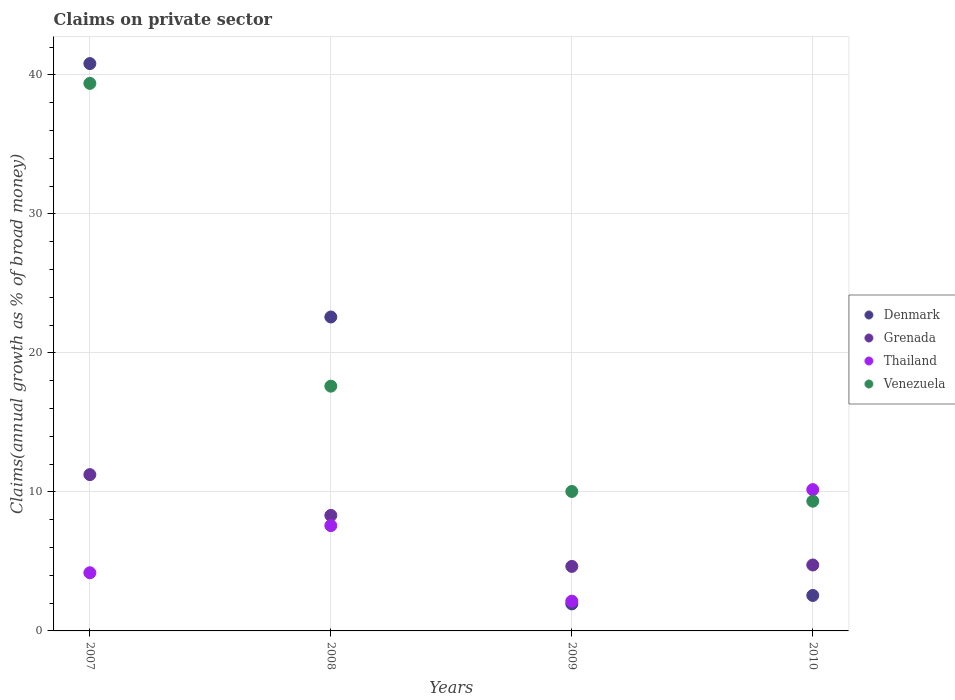How many different coloured dotlines are there?
Provide a short and direct response. 4. Is the number of dotlines equal to the number of legend labels?
Offer a terse response. Yes. What is the percentage of broad money claimed on private sector in Grenada in 2008?
Provide a succinct answer. 8.31. Across all years, what is the maximum percentage of broad money claimed on private sector in Denmark?
Your answer should be very brief. 40.82. Across all years, what is the minimum percentage of broad money claimed on private sector in Venezuela?
Your answer should be very brief. 9.33. In which year was the percentage of broad money claimed on private sector in Grenada minimum?
Your response must be concise. 2009. What is the total percentage of broad money claimed on private sector in Grenada in the graph?
Your response must be concise. 28.94. What is the difference between the percentage of broad money claimed on private sector in Venezuela in 2008 and that in 2010?
Your answer should be compact. 8.27. What is the difference between the percentage of broad money claimed on private sector in Venezuela in 2010 and the percentage of broad money claimed on private sector in Grenada in 2009?
Your answer should be compact. 4.69. What is the average percentage of broad money claimed on private sector in Thailand per year?
Make the answer very short. 6.02. In the year 2010, what is the difference between the percentage of broad money claimed on private sector in Denmark and percentage of broad money claimed on private sector in Thailand?
Provide a short and direct response. -7.61. What is the ratio of the percentage of broad money claimed on private sector in Grenada in 2007 to that in 2009?
Give a very brief answer. 2.42. What is the difference between the highest and the second highest percentage of broad money claimed on private sector in Thailand?
Give a very brief answer. 2.59. What is the difference between the highest and the lowest percentage of broad money claimed on private sector in Venezuela?
Keep it short and to the point. 30.06. Is the sum of the percentage of broad money claimed on private sector in Venezuela in 2007 and 2010 greater than the maximum percentage of broad money claimed on private sector in Denmark across all years?
Your answer should be very brief. Yes. Is it the case that in every year, the sum of the percentage of broad money claimed on private sector in Thailand and percentage of broad money claimed on private sector in Venezuela  is greater than the sum of percentage of broad money claimed on private sector in Denmark and percentage of broad money claimed on private sector in Grenada?
Provide a succinct answer. No. Is it the case that in every year, the sum of the percentage of broad money claimed on private sector in Venezuela and percentage of broad money claimed on private sector in Denmark  is greater than the percentage of broad money claimed on private sector in Grenada?
Offer a terse response. Yes. Is the percentage of broad money claimed on private sector in Venezuela strictly greater than the percentage of broad money claimed on private sector in Denmark over the years?
Your response must be concise. No. Is the percentage of broad money claimed on private sector in Denmark strictly less than the percentage of broad money claimed on private sector in Grenada over the years?
Provide a succinct answer. No. How many dotlines are there?
Offer a terse response. 4. What is the difference between two consecutive major ticks on the Y-axis?
Your response must be concise. 10. Does the graph contain grids?
Offer a very short reply. Yes. Where does the legend appear in the graph?
Offer a terse response. Center right. How many legend labels are there?
Offer a very short reply. 4. What is the title of the graph?
Offer a terse response. Claims on private sector. What is the label or title of the Y-axis?
Give a very brief answer. Claims(annual growth as % of broad money). What is the Claims(annual growth as % of broad money) in Denmark in 2007?
Make the answer very short. 40.82. What is the Claims(annual growth as % of broad money) of Grenada in 2007?
Provide a short and direct response. 11.25. What is the Claims(annual growth as % of broad money) of Thailand in 2007?
Make the answer very short. 4.18. What is the Claims(annual growth as % of broad money) of Venezuela in 2007?
Give a very brief answer. 39.39. What is the Claims(annual growth as % of broad money) in Denmark in 2008?
Provide a short and direct response. 22.59. What is the Claims(annual growth as % of broad money) of Grenada in 2008?
Keep it short and to the point. 8.31. What is the Claims(annual growth as % of broad money) of Thailand in 2008?
Provide a succinct answer. 7.58. What is the Claims(annual growth as % of broad money) of Venezuela in 2008?
Ensure brevity in your answer.  17.61. What is the Claims(annual growth as % of broad money) of Denmark in 2009?
Provide a succinct answer. 1.94. What is the Claims(annual growth as % of broad money) of Grenada in 2009?
Your answer should be very brief. 4.64. What is the Claims(annual growth as % of broad money) of Thailand in 2009?
Ensure brevity in your answer.  2.14. What is the Claims(annual growth as % of broad money) in Venezuela in 2009?
Ensure brevity in your answer.  10.03. What is the Claims(annual growth as % of broad money) in Denmark in 2010?
Give a very brief answer. 2.55. What is the Claims(annual growth as % of broad money) of Grenada in 2010?
Your response must be concise. 4.75. What is the Claims(annual growth as % of broad money) in Thailand in 2010?
Give a very brief answer. 10.17. What is the Claims(annual growth as % of broad money) in Venezuela in 2010?
Provide a succinct answer. 9.33. Across all years, what is the maximum Claims(annual growth as % of broad money) in Denmark?
Your answer should be very brief. 40.82. Across all years, what is the maximum Claims(annual growth as % of broad money) of Grenada?
Your response must be concise. 11.25. Across all years, what is the maximum Claims(annual growth as % of broad money) in Thailand?
Ensure brevity in your answer.  10.17. Across all years, what is the maximum Claims(annual growth as % of broad money) of Venezuela?
Provide a succinct answer. 39.39. Across all years, what is the minimum Claims(annual growth as % of broad money) in Denmark?
Provide a succinct answer. 1.94. Across all years, what is the minimum Claims(annual growth as % of broad money) in Grenada?
Your response must be concise. 4.64. Across all years, what is the minimum Claims(annual growth as % of broad money) of Thailand?
Give a very brief answer. 2.14. Across all years, what is the minimum Claims(annual growth as % of broad money) of Venezuela?
Offer a terse response. 9.33. What is the total Claims(annual growth as % of broad money) in Denmark in the graph?
Your response must be concise. 67.9. What is the total Claims(annual growth as % of broad money) of Grenada in the graph?
Provide a succinct answer. 28.94. What is the total Claims(annual growth as % of broad money) in Thailand in the graph?
Offer a very short reply. 24.07. What is the total Claims(annual growth as % of broad money) of Venezuela in the graph?
Ensure brevity in your answer.  76.37. What is the difference between the Claims(annual growth as % of broad money) in Denmark in 2007 and that in 2008?
Provide a succinct answer. 18.23. What is the difference between the Claims(annual growth as % of broad money) in Grenada in 2007 and that in 2008?
Offer a terse response. 2.93. What is the difference between the Claims(annual growth as % of broad money) in Thailand in 2007 and that in 2008?
Your answer should be very brief. -3.39. What is the difference between the Claims(annual growth as % of broad money) in Venezuela in 2007 and that in 2008?
Offer a terse response. 21.78. What is the difference between the Claims(annual growth as % of broad money) of Denmark in 2007 and that in 2009?
Give a very brief answer. 38.87. What is the difference between the Claims(annual growth as % of broad money) in Grenada in 2007 and that in 2009?
Your answer should be very brief. 6.6. What is the difference between the Claims(annual growth as % of broad money) in Thailand in 2007 and that in 2009?
Offer a terse response. 2.04. What is the difference between the Claims(annual growth as % of broad money) of Venezuela in 2007 and that in 2009?
Offer a very short reply. 29.36. What is the difference between the Claims(annual growth as % of broad money) of Denmark in 2007 and that in 2010?
Keep it short and to the point. 38.27. What is the difference between the Claims(annual growth as % of broad money) in Thailand in 2007 and that in 2010?
Make the answer very short. -5.98. What is the difference between the Claims(annual growth as % of broad money) in Venezuela in 2007 and that in 2010?
Offer a very short reply. 30.06. What is the difference between the Claims(annual growth as % of broad money) in Denmark in 2008 and that in 2009?
Provide a short and direct response. 20.64. What is the difference between the Claims(annual growth as % of broad money) of Grenada in 2008 and that in 2009?
Your answer should be very brief. 3.67. What is the difference between the Claims(annual growth as % of broad money) in Thailand in 2008 and that in 2009?
Provide a succinct answer. 5.44. What is the difference between the Claims(annual growth as % of broad money) in Venezuela in 2008 and that in 2009?
Give a very brief answer. 7.58. What is the difference between the Claims(annual growth as % of broad money) of Denmark in 2008 and that in 2010?
Your answer should be very brief. 20.03. What is the difference between the Claims(annual growth as % of broad money) of Grenada in 2008 and that in 2010?
Offer a very short reply. 3.57. What is the difference between the Claims(annual growth as % of broad money) in Thailand in 2008 and that in 2010?
Make the answer very short. -2.59. What is the difference between the Claims(annual growth as % of broad money) of Venezuela in 2008 and that in 2010?
Your response must be concise. 8.27. What is the difference between the Claims(annual growth as % of broad money) in Denmark in 2009 and that in 2010?
Your answer should be very brief. -0.61. What is the difference between the Claims(annual growth as % of broad money) of Grenada in 2009 and that in 2010?
Your response must be concise. -0.1. What is the difference between the Claims(annual growth as % of broad money) of Thailand in 2009 and that in 2010?
Your answer should be compact. -8.03. What is the difference between the Claims(annual growth as % of broad money) in Venezuela in 2009 and that in 2010?
Keep it short and to the point. 0.7. What is the difference between the Claims(annual growth as % of broad money) of Denmark in 2007 and the Claims(annual growth as % of broad money) of Grenada in 2008?
Your answer should be compact. 32.51. What is the difference between the Claims(annual growth as % of broad money) of Denmark in 2007 and the Claims(annual growth as % of broad money) of Thailand in 2008?
Ensure brevity in your answer.  33.24. What is the difference between the Claims(annual growth as % of broad money) in Denmark in 2007 and the Claims(annual growth as % of broad money) in Venezuela in 2008?
Your response must be concise. 23.21. What is the difference between the Claims(annual growth as % of broad money) of Grenada in 2007 and the Claims(annual growth as % of broad money) of Thailand in 2008?
Your answer should be very brief. 3.67. What is the difference between the Claims(annual growth as % of broad money) of Grenada in 2007 and the Claims(annual growth as % of broad money) of Venezuela in 2008?
Keep it short and to the point. -6.36. What is the difference between the Claims(annual growth as % of broad money) in Thailand in 2007 and the Claims(annual growth as % of broad money) in Venezuela in 2008?
Provide a short and direct response. -13.43. What is the difference between the Claims(annual growth as % of broad money) of Denmark in 2007 and the Claims(annual growth as % of broad money) of Grenada in 2009?
Provide a succinct answer. 36.18. What is the difference between the Claims(annual growth as % of broad money) in Denmark in 2007 and the Claims(annual growth as % of broad money) in Thailand in 2009?
Ensure brevity in your answer.  38.68. What is the difference between the Claims(annual growth as % of broad money) in Denmark in 2007 and the Claims(annual growth as % of broad money) in Venezuela in 2009?
Your response must be concise. 30.78. What is the difference between the Claims(annual growth as % of broad money) in Grenada in 2007 and the Claims(annual growth as % of broad money) in Thailand in 2009?
Offer a very short reply. 9.11. What is the difference between the Claims(annual growth as % of broad money) of Grenada in 2007 and the Claims(annual growth as % of broad money) of Venezuela in 2009?
Your answer should be very brief. 1.21. What is the difference between the Claims(annual growth as % of broad money) in Thailand in 2007 and the Claims(annual growth as % of broad money) in Venezuela in 2009?
Keep it short and to the point. -5.85. What is the difference between the Claims(annual growth as % of broad money) of Denmark in 2007 and the Claims(annual growth as % of broad money) of Grenada in 2010?
Offer a terse response. 36.07. What is the difference between the Claims(annual growth as % of broad money) of Denmark in 2007 and the Claims(annual growth as % of broad money) of Thailand in 2010?
Make the answer very short. 30.65. What is the difference between the Claims(annual growth as % of broad money) of Denmark in 2007 and the Claims(annual growth as % of broad money) of Venezuela in 2010?
Your answer should be very brief. 31.48. What is the difference between the Claims(annual growth as % of broad money) of Grenada in 2007 and the Claims(annual growth as % of broad money) of Thailand in 2010?
Provide a succinct answer. 1.08. What is the difference between the Claims(annual growth as % of broad money) of Grenada in 2007 and the Claims(annual growth as % of broad money) of Venezuela in 2010?
Keep it short and to the point. 1.91. What is the difference between the Claims(annual growth as % of broad money) in Thailand in 2007 and the Claims(annual growth as % of broad money) in Venezuela in 2010?
Make the answer very short. -5.15. What is the difference between the Claims(annual growth as % of broad money) in Denmark in 2008 and the Claims(annual growth as % of broad money) in Grenada in 2009?
Provide a succinct answer. 17.94. What is the difference between the Claims(annual growth as % of broad money) of Denmark in 2008 and the Claims(annual growth as % of broad money) of Thailand in 2009?
Offer a terse response. 20.45. What is the difference between the Claims(annual growth as % of broad money) in Denmark in 2008 and the Claims(annual growth as % of broad money) in Venezuela in 2009?
Provide a succinct answer. 12.55. What is the difference between the Claims(annual growth as % of broad money) in Grenada in 2008 and the Claims(annual growth as % of broad money) in Thailand in 2009?
Offer a very short reply. 6.17. What is the difference between the Claims(annual growth as % of broad money) of Grenada in 2008 and the Claims(annual growth as % of broad money) of Venezuela in 2009?
Offer a terse response. -1.72. What is the difference between the Claims(annual growth as % of broad money) in Thailand in 2008 and the Claims(annual growth as % of broad money) in Venezuela in 2009?
Your response must be concise. -2.46. What is the difference between the Claims(annual growth as % of broad money) of Denmark in 2008 and the Claims(annual growth as % of broad money) of Grenada in 2010?
Provide a succinct answer. 17.84. What is the difference between the Claims(annual growth as % of broad money) in Denmark in 2008 and the Claims(annual growth as % of broad money) in Thailand in 2010?
Provide a short and direct response. 12.42. What is the difference between the Claims(annual growth as % of broad money) in Denmark in 2008 and the Claims(annual growth as % of broad money) in Venezuela in 2010?
Provide a succinct answer. 13.25. What is the difference between the Claims(annual growth as % of broad money) in Grenada in 2008 and the Claims(annual growth as % of broad money) in Thailand in 2010?
Your answer should be compact. -1.86. What is the difference between the Claims(annual growth as % of broad money) in Grenada in 2008 and the Claims(annual growth as % of broad money) in Venezuela in 2010?
Your response must be concise. -1.02. What is the difference between the Claims(annual growth as % of broad money) of Thailand in 2008 and the Claims(annual growth as % of broad money) of Venezuela in 2010?
Provide a succinct answer. -1.76. What is the difference between the Claims(annual growth as % of broad money) of Denmark in 2009 and the Claims(annual growth as % of broad money) of Grenada in 2010?
Offer a very short reply. -2.8. What is the difference between the Claims(annual growth as % of broad money) of Denmark in 2009 and the Claims(annual growth as % of broad money) of Thailand in 2010?
Your answer should be compact. -8.22. What is the difference between the Claims(annual growth as % of broad money) of Denmark in 2009 and the Claims(annual growth as % of broad money) of Venezuela in 2010?
Your answer should be very brief. -7.39. What is the difference between the Claims(annual growth as % of broad money) in Grenada in 2009 and the Claims(annual growth as % of broad money) in Thailand in 2010?
Offer a very short reply. -5.52. What is the difference between the Claims(annual growth as % of broad money) of Grenada in 2009 and the Claims(annual growth as % of broad money) of Venezuela in 2010?
Make the answer very short. -4.69. What is the difference between the Claims(annual growth as % of broad money) in Thailand in 2009 and the Claims(annual growth as % of broad money) in Venezuela in 2010?
Give a very brief answer. -7.19. What is the average Claims(annual growth as % of broad money) of Denmark per year?
Offer a very short reply. 16.98. What is the average Claims(annual growth as % of broad money) of Grenada per year?
Make the answer very short. 7.24. What is the average Claims(annual growth as % of broad money) in Thailand per year?
Your response must be concise. 6.02. What is the average Claims(annual growth as % of broad money) in Venezuela per year?
Provide a short and direct response. 19.09. In the year 2007, what is the difference between the Claims(annual growth as % of broad money) of Denmark and Claims(annual growth as % of broad money) of Grenada?
Make the answer very short. 29.57. In the year 2007, what is the difference between the Claims(annual growth as % of broad money) in Denmark and Claims(annual growth as % of broad money) in Thailand?
Give a very brief answer. 36.63. In the year 2007, what is the difference between the Claims(annual growth as % of broad money) in Denmark and Claims(annual growth as % of broad money) in Venezuela?
Provide a succinct answer. 1.42. In the year 2007, what is the difference between the Claims(annual growth as % of broad money) of Grenada and Claims(annual growth as % of broad money) of Thailand?
Provide a short and direct response. 7.06. In the year 2007, what is the difference between the Claims(annual growth as % of broad money) in Grenada and Claims(annual growth as % of broad money) in Venezuela?
Your answer should be compact. -28.15. In the year 2007, what is the difference between the Claims(annual growth as % of broad money) of Thailand and Claims(annual growth as % of broad money) of Venezuela?
Your answer should be compact. -35.21. In the year 2008, what is the difference between the Claims(annual growth as % of broad money) of Denmark and Claims(annual growth as % of broad money) of Grenada?
Provide a short and direct response. 14.28. In the year 2008, what is the difference between the Claims(annual growth as % of broad money) in Denmark and Claims(annual growth as % of broad money) in Thailand?
Offer a terse response. 15.01. In the year 2008, what is the difference between the Claims(annual growth as % of broad money) of Denmark and Claims(annual growth as % of broad money) of Venezuela?
Provide a short and direct response. 4.98. In the year 2008, what is the difference between the Claims(annual growth as % of broad money) of Grenada and Claims(annual growth as % of broad money) of Thailand?
Your answer should be very brief. 0.73. In the year 2008, what is the difference between the Claims(annual growth as % of broad money) in Grenada and Claims(annual growth as % of broad money) in Venezuela?
Keep it short and to the point. -9.3. In the year 2008, what is the difference between the Claims(annual growth as % of broad money) in Thailand and Claims(annual growth as % of broad money) in Venezuela?
Your answer should be compact. -10.03. In the year 2009, what is the difference between the Claims(annual growth as % of broad money) in Denmark and Claims(annual growth as % of broad money) in Grenada?
Give a very brief answer. -2.7. In the year 2009, what is the difference between the Claims(annual growth as % of broad money) in Denmark and Claims(annual growth as % of broad money) in Thailand?
Provide a short and direct response. -0.2. In the year 2009, what is the difference between the Claims(annual growth as % of broad money) of Denmark and Claims(annual growth as % of broad money) of Venezuela?
Give a very brief answer. -8.09. In the year 2009, what is the difference between the Claims(annual growth as % of broad money) of Grenada and Claims(annual growth as % of broad money) of Thailand?
Offer a very short reply. 2.5. In the year 2009, what is the difference between the Claims(annual growth as % of broad money) in Grenada and Claims(annual growth as % of broad money) in Venezuela?
Ensure brevity in your answer.  -5.39. In the year 2009, what is the difference between the Claims(annual growth as % of broad money) of Thailand and Claims(annual growth as % of broad money) of Venezuela?
Provide a short and direct response. -7.89. In the year 2010, what is the difference between the Claims(annual growth as % of broad money) of Denmark and Claims(annual growth as % of broad money) of Grenada?
Provide a succinct answer. -2.19. In the year 2010, what is the difference between the Claims(annual growth as % of broad money) in Denmark and Claims(annual growth as % of broad money) in Thailand?
Your answer should be compact. -7.61. In the year 2010, what is the difference between the Claims(annual growth as % of broad money) of Denmark and Claims(annual growth as % of broad money) of Venezuela?
Make the answer very short. -6.78. In the year 2010, what is the difference between the Claims(annual growth as % of broad money) in Grenada and Claims(annual growth as % of broad money) in Thailand?
Offer a terse response. -5.42. In the year 2010, what is the difference between the Claims(annual growth as % of broad money) in Grenada and Claims(annual growth as % of broad money) in Venezuela?
Your answer should be very brief. -4.59. In the year 2010, what is the difference between the Claims(annual growth as % of broad money) in Thailand and Claims(annual growth as % of broad money) in Venezuela?
Provide a succinct answer. 0.83. What is the ratio of the Claims(annual growth as % of broad money) in Denmark in 2007 to that in 2008?
Keep it short and to the point. 1.81. What is the ratio of the Claims(annual growth as % of broad money) of Grenada in 2007 to that in 2008?
Ensure brevity in your answer.  1.35. What is the ratio of the Claims(annual growth as % of broad money) of Thailand in 2007 to that in 2008?
Give a very brief answer. 0.55. What is the ratio of the Claims(annual growth as % of broad money) in Venezuela in 2007 to that in 2008?
Your answer should be very brief. 2.24. What is the ratio of the Claims(annual growth as % of broad money) in Denmark in 2007 to that in 2009?
Offer a terse response. 20.99. What is the ratio of the Claims(annual growth as % of broad money) in Grenada in 2007 to that in 2009?
Your response must be concise. 2.42. What is the ratio of the Claims(annual growth as % of broad money) of Thailand in 2007 to that in 2009?
Provide a succinct answer. 1.96. What is the ratio of the Claims(annual growth as % of broad money) of Venezuela in 2007 to that in 2009?
Keep it short and to the point. 3.93. What is the ratio of the Claims(annual growth as % of broad money) in Denmark in 2007 to that in 2010?
Your answer should be very brief. 16. What is the ratio of the Claims(annual growth as % of broad money) of Grenada in 2007 to that in 2010?
Your answer should be compact. 2.37. What is the ratio of the Claims(annual growth as % of broad money) in Thailand in 2007 to that in 2010?
Offer a very short reply. 0.41. What is the ratio of the Claims(annual growth as % of broad money) of Venezuela in 2007 to that in 2010?
Keep it short and to the point. 4.22. What is the ratio of the Claims(annual growth as % of broad money) of Denmark in 2008 to that in 2009?
Give a very brief answer. 11.61. What is the ratio of the Claims(annual growth as % of broad money) in Grenada in 2008 to that in 2009?
Your answer should be compact. 1.79. What is the ratio of the Claims(annual growth as % of broad money) of Thailand in 2008 to that in 2009?
Your response must be concise. 3.54. What is the ratio of the Claims(annual growth as % of broad money) of Venezuela in 2008 to that in 2009?
Give a very brief answer. 1.75. What is the ratio of the Claims(annual growth as % of broad money) of Denmark in 2008 to that in 2010?
Your response must be concise. 8.85. What is the ratio of the Claims(annual growth as % of broad money) of Grenada in 2008 to that in 2010?
Your answer should be compact. 1.75. What is the ratio of the Claims(annual growth as % of broad money) in Thailand in 2008 to that in 2010?
Make the answer very short. 0.75. What is the ratio of the Claims(annual growth as % of broad money) in Venezuela in 2008 to that in 2010?
Make the answer very short. 1.89. What is the ratio of the Claims(annual growth as % of broad money) of Denmark in 2009 to that in 2010?
Provide a short and direct response. 0.76. What is the ratio of the Claims(annual growth as % of broad money) in Grenada in 2009 to that in 2010?
Keep it short and to the point. 0.98. What is the ratio of the Claims(annual growth as % of broad money) of Thailand in 2009 to that in 2010?
Provide a short and direct response. 0.21. What is the ratio of the Claims(annual growth as % of broad money) in Venezuela in 2009 to that in 2010?
Offer a very short reply. 1.07. What is the difference between the highest and the second highest Claims(annual growth as % of broad money) in Denmark?
Keep it short and to the point. 18.23. What is the difference between the highest and the second highest Claims(annual growth as % of broad money) of Grenada?
Your response must be concise. 2.93. What is the difference between the highest and the second highest Claims(annual growth as % of broad money) in Thailand?
Give a very brief answer. 2.59. What is the difference between the highest and the second highest Claims(annual growth as % of broad money) of Venezuela?
Ensure brevity in your answer.  21.78. What is the difference between the highest and the lowest Claims(annual growth as % of broad money) of Denmark?
Offer a very short reply. 38.87. What is the difference between the highest and the lowest Claims(annual growth as % of broad money) of Grenada?
Ensure brevity in your answer.  6.6. What is the difference between the highest and the lowest Claims(annual growth as % of broad money) of Thailand?
Your answer should be compact. 8.03. What is the difference between the highest and the lowest Claims(annual growth as % of broad money) in Venezuela?
Offer a terse response. 30.06. 